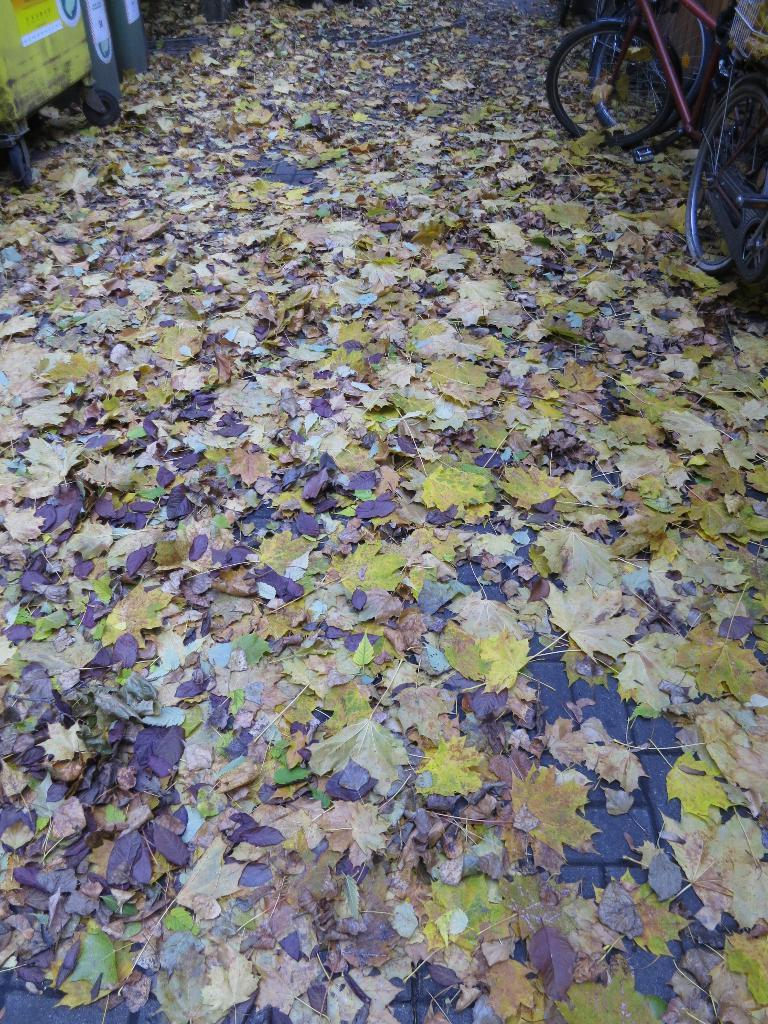What type of vegetation is present at the bottom of the image? There are leaves at the bottom of the image. What mode of transportation can be seen on the right side of the image? There is a bicycle on the right side of the image. What object is located on the left side of the image? There appears to be a trolley on the left side of the image. Can you tell me how many babies are visible in the image? There are no babies present in the image. What is the name of the girl standing next to the trolley? There is no girl present in the image, only a trolley. 